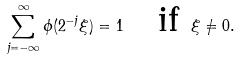Convert formula to latex. <formula><loc_0><loc_0><loc_500><loc_500>\sum _ { j = - \infty } ^ { \infty } \phi ( 2 ^ { - j } \xi ) = 1 \quad \text {if } \xi \neq 0 .</formula> 